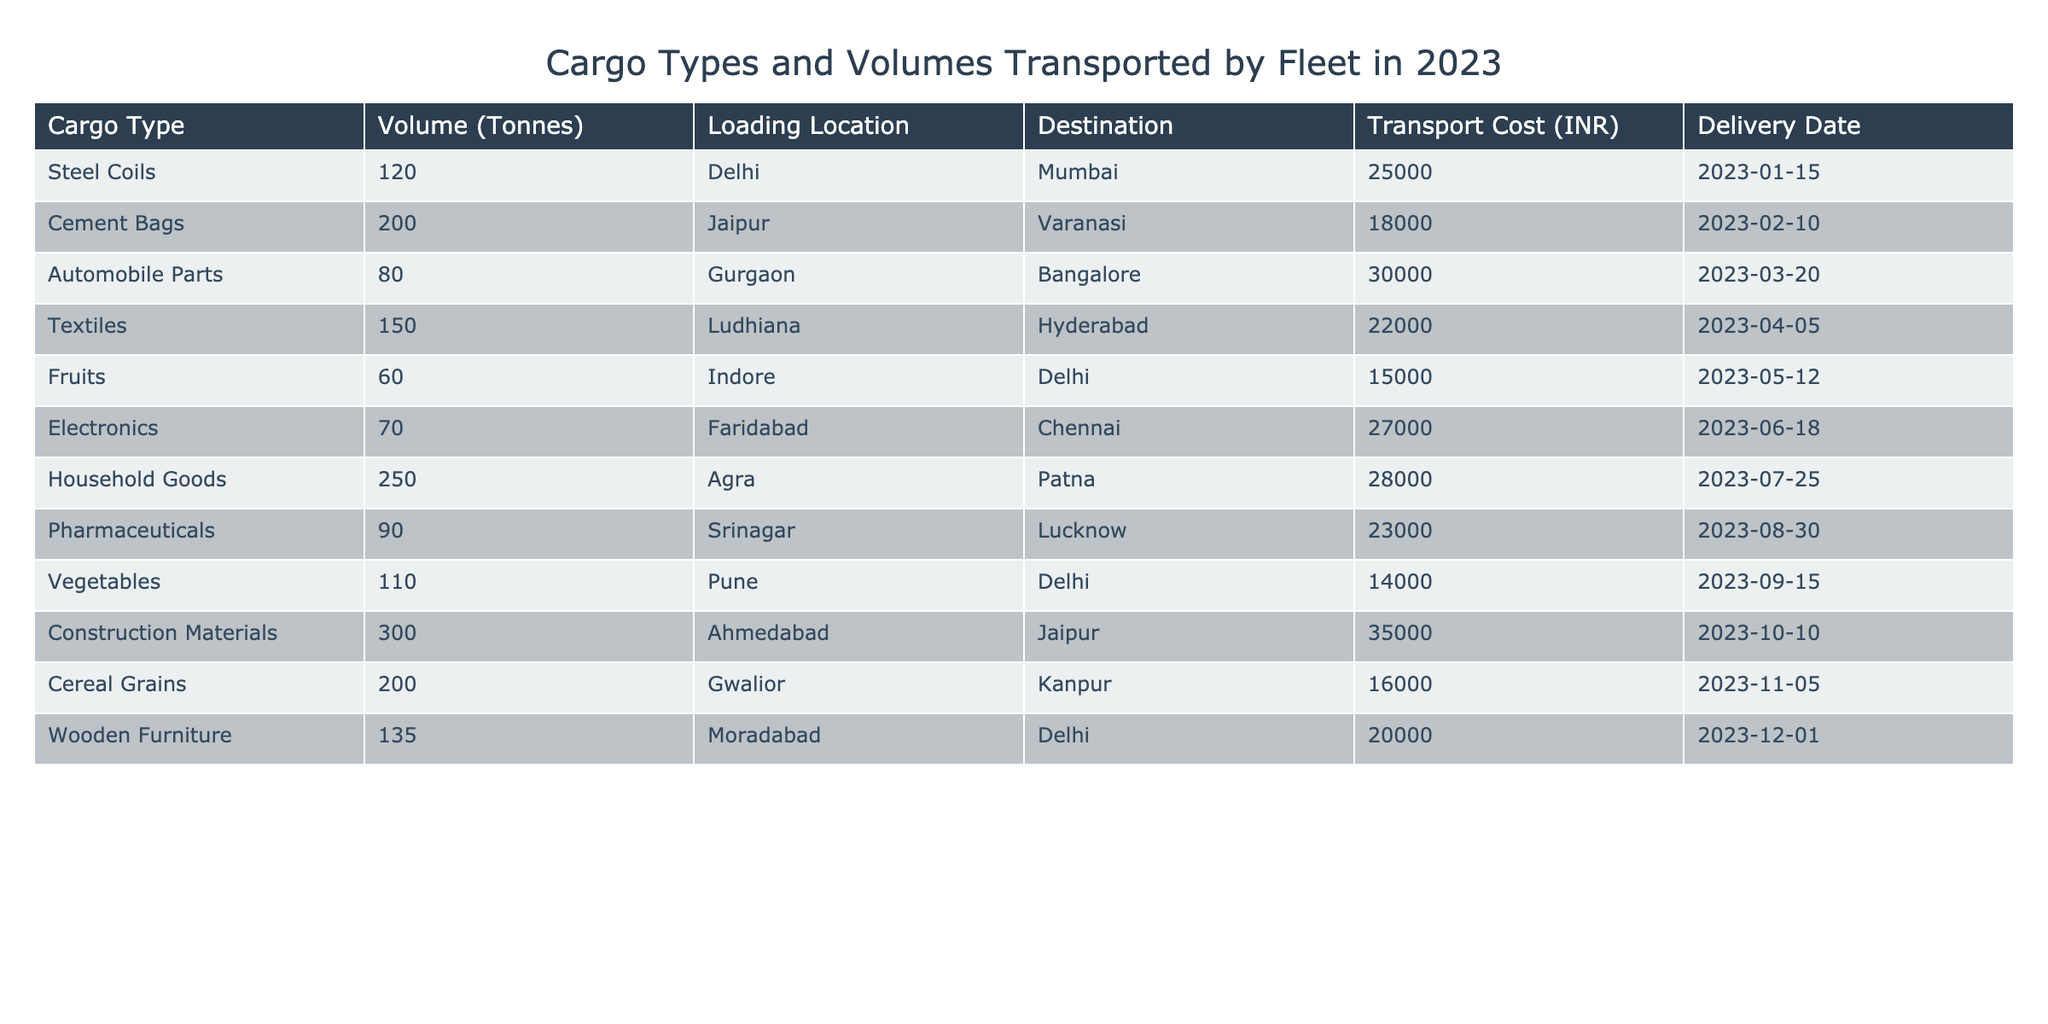What is the highest volume of cargo transported in 2023? The highest volume in the table is for Construction Materials with a volume of 300 tonnes.
Answer: 300 tonnes Which cargo type had the lowest transport cost? Looking at the transport costs associated with each cargo type, Fruits has the lowest cost of 15,000 INR.
Answer: 15,000 INR How many types of cargo were transported to Delhi? The cargo types going to Delhi are Fruits, Vegetables, and Wooden Furniture, totaling three types.
Answer: 3 types What is the total volume of automobiles and electronics transported? The volume for Automobile Parts is 80 tonnes and for Electronics is 70 tonnes. Summing these gives us 80 + 70 = 150 tonnes.
Answer: 150 tonnes Which two cargo types had a total transport cost of 50,000 INR or more? The transport costs for Household Goods (28,000 INR) and Construction Materials (35,000 INR) total 63,000 INR, which is more than 50,000 INR.
Answer: Household Goods and Construction Materials Is it true that the delivery date for Cement Bags is before the delivery date for Electronic goods? The delivery date for Cement Bags is 2023-02-10 and for Electronics, it is 2023-06-18. Since February comes before June, this statement is true.
Answer: True What is the average transport cost for the cargo types listed? Summing all the transport costs gives 25,000 + 18,000 + 30,000 + 22,000 + 15,000 + 27,000 + 28,000 + 23,000 + 14,000 + 35,000 + 16,000 + 20,000 =  300,000. Dividing this by the number of cargo types (12) gives an average of 300,000 / 12 = 25,000 INR.
Answer: 25,000 INR If Steel Coils were transported from a different location, would that affect their transportation cost? Since the transportation cost can vary based on distance and location, changing the loading location could potentially change the cost. Thus, it can affect the cost.
Answer: Yes What is the total volume of the cargo transported from Jaipur and Ahmedabad combined? The volume from Jaipur (Cement Bags) is 200 tonnes, and from Ahmedabad (Construction Materials) is 300 tonnes. Thus, the total volume is 200 + 300 = 500 tonnes.
Answer: 500 tonnes Which cargo was transported from the northernmost location listed? The northernmost location in the list is Srinagar, from which Pharmaceuticals were transported.
Answer: Pharmaceuticals 